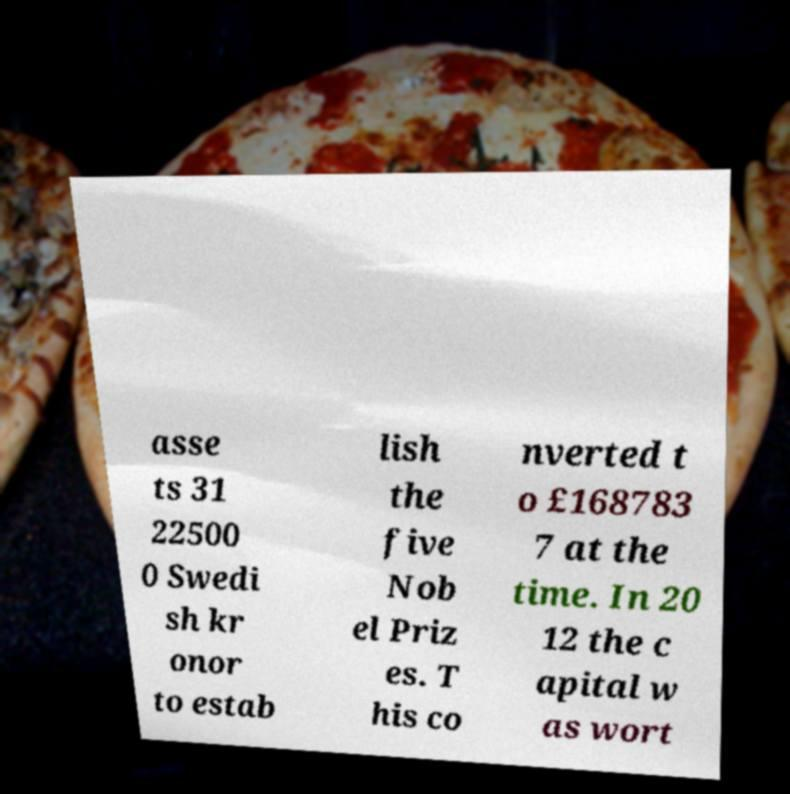Can you read and provide the text displayed in the image?This photo seems to have some interesting text. Can you extract and type it out for me? asse ts 31 22500 0 Swedi sh kr onor to estab lish the five Nob el Priz es. T his co nverted t o £168783 7 at the time. In 20 12 the c apital w as wort 